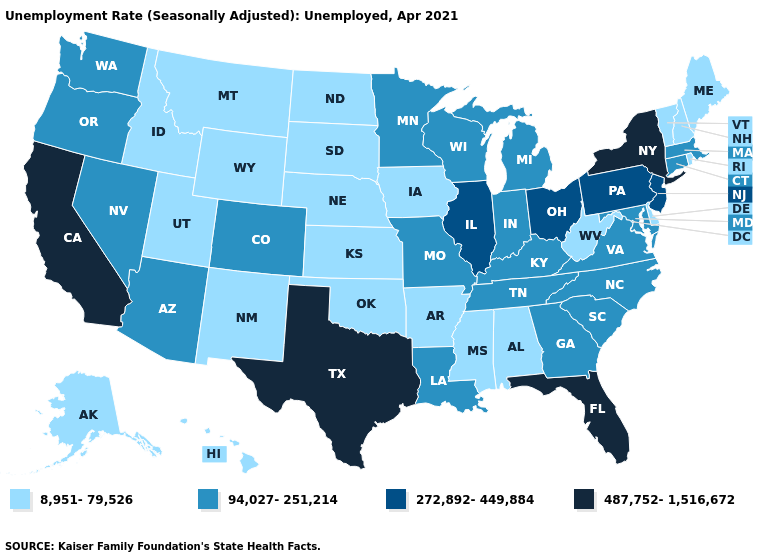Does the map have missing data?
Write a very short answer. No. What is the value of Nevada?
Short answer required. 94,027-251,214. Does California have the highest value in the USA?
Concise answer only. Yes. Which states have the lowest value in the South?
Write a very short answer. Alabama, Arkansas, Delaware, Mississippi, Oklahoma, West Virginia. What is the lowest value in states that border Nevada?
Be succinct. 8,951-79,526. What is the value of Illinois?
Give a very brief answer. 272,892-449,884. What is the value of Alaska?
Answer briefly. 8,951-79,526. Does the map have missing data?
Keep it brief. No. Among the states that border Texas , does Louisiana have the lowest value?
Answer briefly. No. Does the first symbol in the legend represent the smallest category?
Keep it brief. Yes. Name the states that have a value in the range 487,752-1,516,672?
Keep it brief. California, Florida, New York, Texas. Is the legend a continuous bar?
Write a very short answer. No. Name the states that have a value in the range 8,951-79,526?
Write a very short answer. Alabama, Alaska, Arkansas, Delaware, Hawaii, Idaho, Iowa, Kansas, Maine, Mississippi, Montana, Nebraska, New Hampshire, New Mexico, North Dakota, Oklahoma, Rhode Island, South Dakota, Utah, Vermont, West Virginia, Wyoming. Does the first symbol in the legend represent the smallest category?
Give a very brief answer. Yes. Is the legend a continuous bar?
Give a very brief answer. No. 